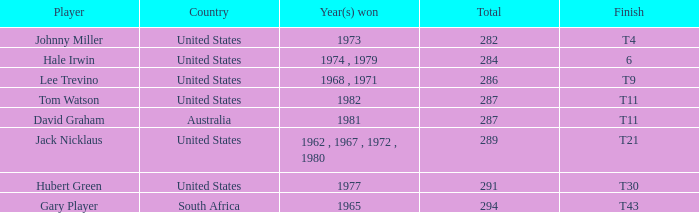WHAT IS THE TOTAL, OF A TO PAR FOR HUBERT GREEN, AND A TOTAL LARGER THAN 291? 0.0. 